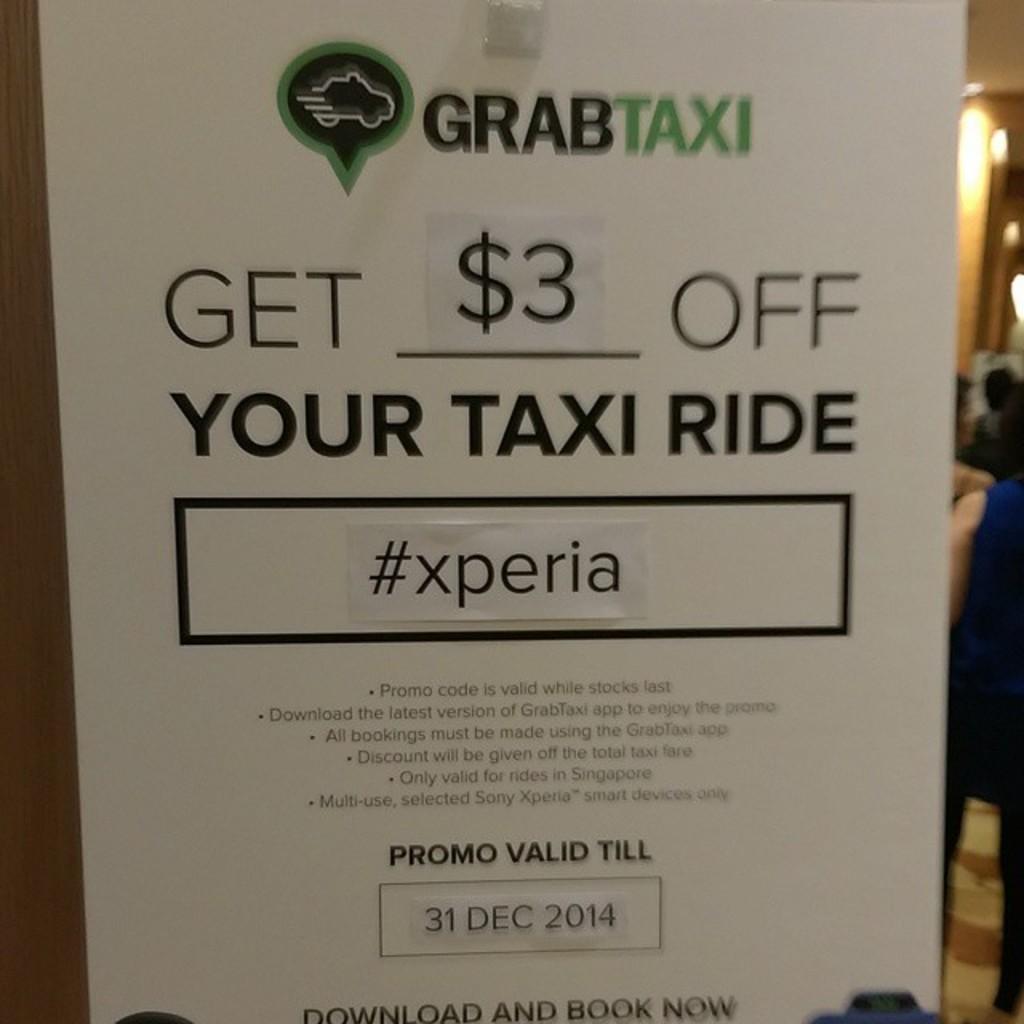How much money do you get off your taxi ride?
Offer a terse response. $3. What is the hastag?
Make the answer very short. #xperia. 